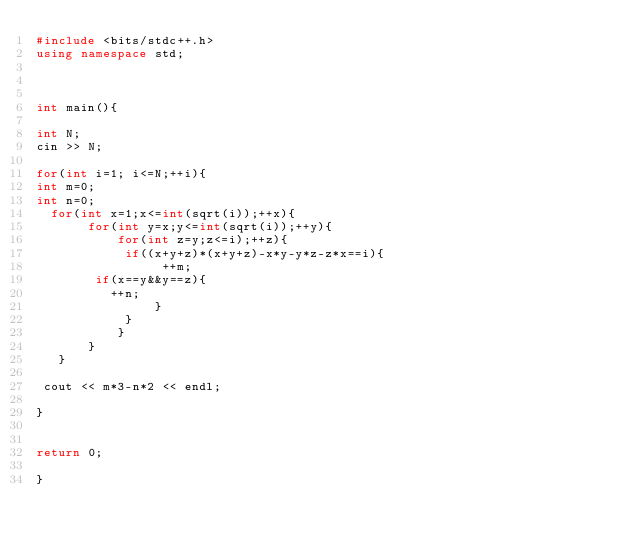<code> <loc_0><loc_0><loc_500><loc_500><_C++_>#include <bits/stdc++.h>
using namespace std;



int main(){

int N;
cin >> N;

for(int i=1; i<=N;++i){ 
int m=0;
int n=0;
  for(int x=1;x<=int(sqrt(i));++x){
       for(int y=x;y<=int(sqrt(i));++y){
           for(int z=y;z<=i);++z){
            if((x+y+z)*(x+y+z)-x*y-y*z-z*x==i){
                 ++m;               
				if(x==y&&y==z){
					++n;
                }
          	}
           }
       }
   } 

 cout << m*3-n*2 << endl;
 
}


return 0;
    
}

</code> 